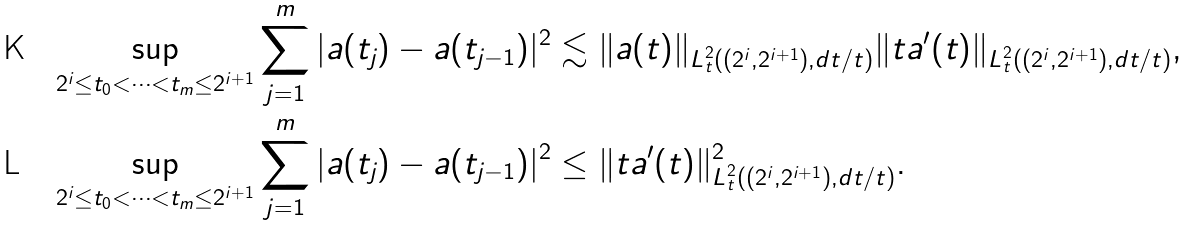Convert formula to latex. <formula><loc_0><loc_0><loc_500><loc_500>& \sup _ { 2 ^ { i } \leq t _ { 0 } < \cdots < t _ { m } \leq 2 ^ { i + 1 } } \sum _ { j = 1 } ^ { m } | a ( t _ { j } ) - a ( t _ { j - 1 } ) | ^ { 2 } \lesssim \| a ( t ) \| _ { L _ { t } ^ { 2 } ( ( 2 ^ { i } , 2 ^ { i + 1 } ) , d t / t ) } \| t a ^ { \prime } ( t ) \| _ { L _ { t } ^ { 2 } ( ( 2 ^ { i } , 2 ^ { i + 1 } ) , d t / t ) } , \\ & \sup _ { 2 ^ { i } \leq t _ { 0 } < \cdots < t _ { m } \leq 2 ^ { i + 1 } } \sum _ { j = 1 } ^ { m } | a ( t _ { j } ) - a ( t _ { j - 1 } ) | ^ { 2 } \leq \| t a ^ { \prime } ( t ) \| ^ { 2 } _ { L _ { t } ^ { 2 } ( ( 2 ^ { i } , 2 ^ { i + 1 } ) , d t / t ) } .</formula> 